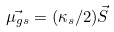Convert formula to latex. <formula><loc_0><loc_0><loc_500><loc_500>\vec { \mu _ { g s } } = ( \kappa _ { s } / 2 ) \vec { S }</formula> 